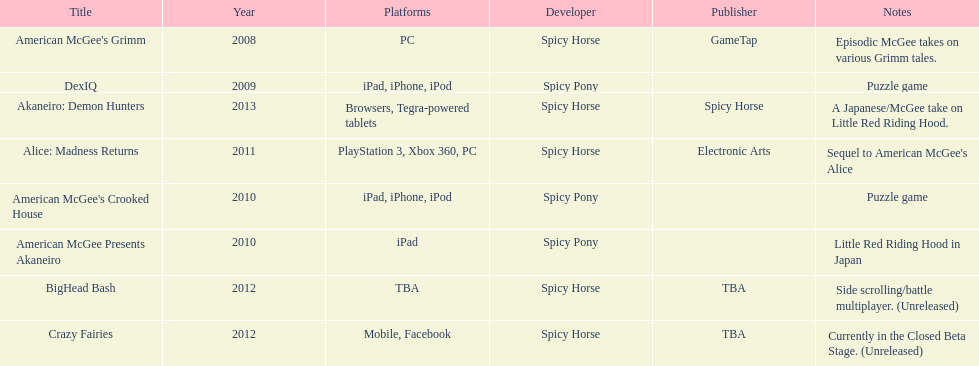According to the table, what is the last title that spicy horse produced? Akaneiro: Demon Hunters. 